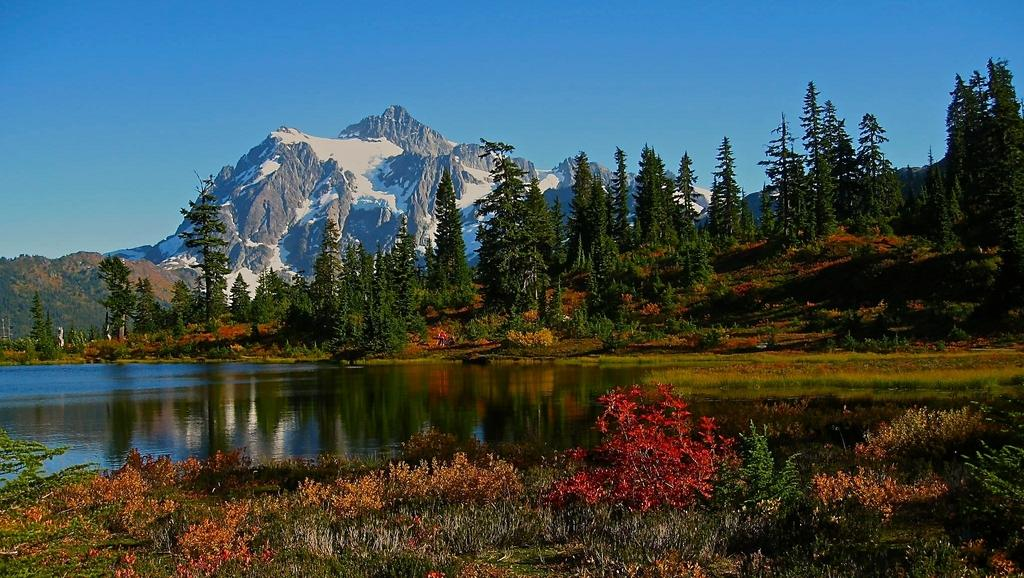What is located in the foreground of the image? There are plants in the foreground of the image. What is in the middle of the image? There is water in the middle of the image. What can be seen in the background of the image? There are trees and mountains in the background of the image. What else is visible in the background of the image? The sky is visible in the background of the image. How many cats are sitting on the spoon in the image? There are no cats or spoons present in the image. What type of payment is being made in the image? There is no payment being made in the image; it features plants, water, trees, mountains, and the sky. 